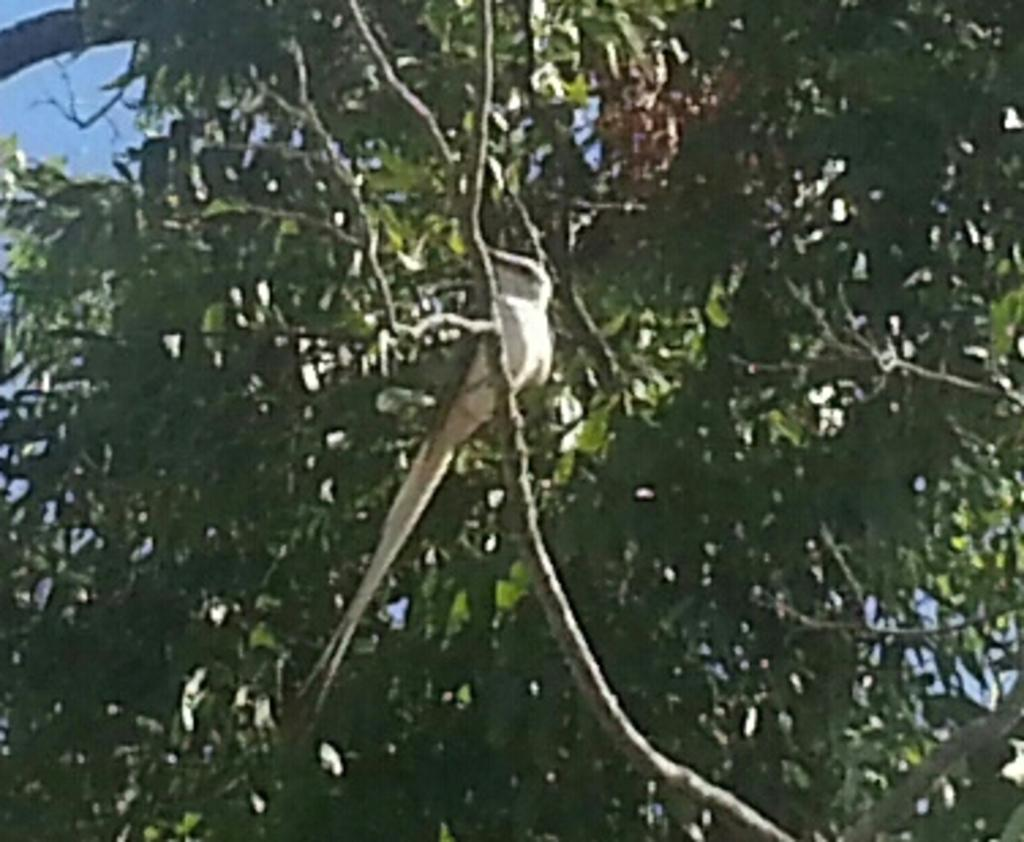What type of animal can be seen in the image? There is a bird in the image. Where is the bird located? The bird is on a branch of a tree. What is the color of the bird? The bird is white in color. What can be seen in the background of the image? There is a sky visible in the background of the image. Are the bird's friends enjoying a feast of corn in the image? There is no indication of friends or a feast of corn in the image; it only features a white bird on a tree branch with a visible sky in the background. 